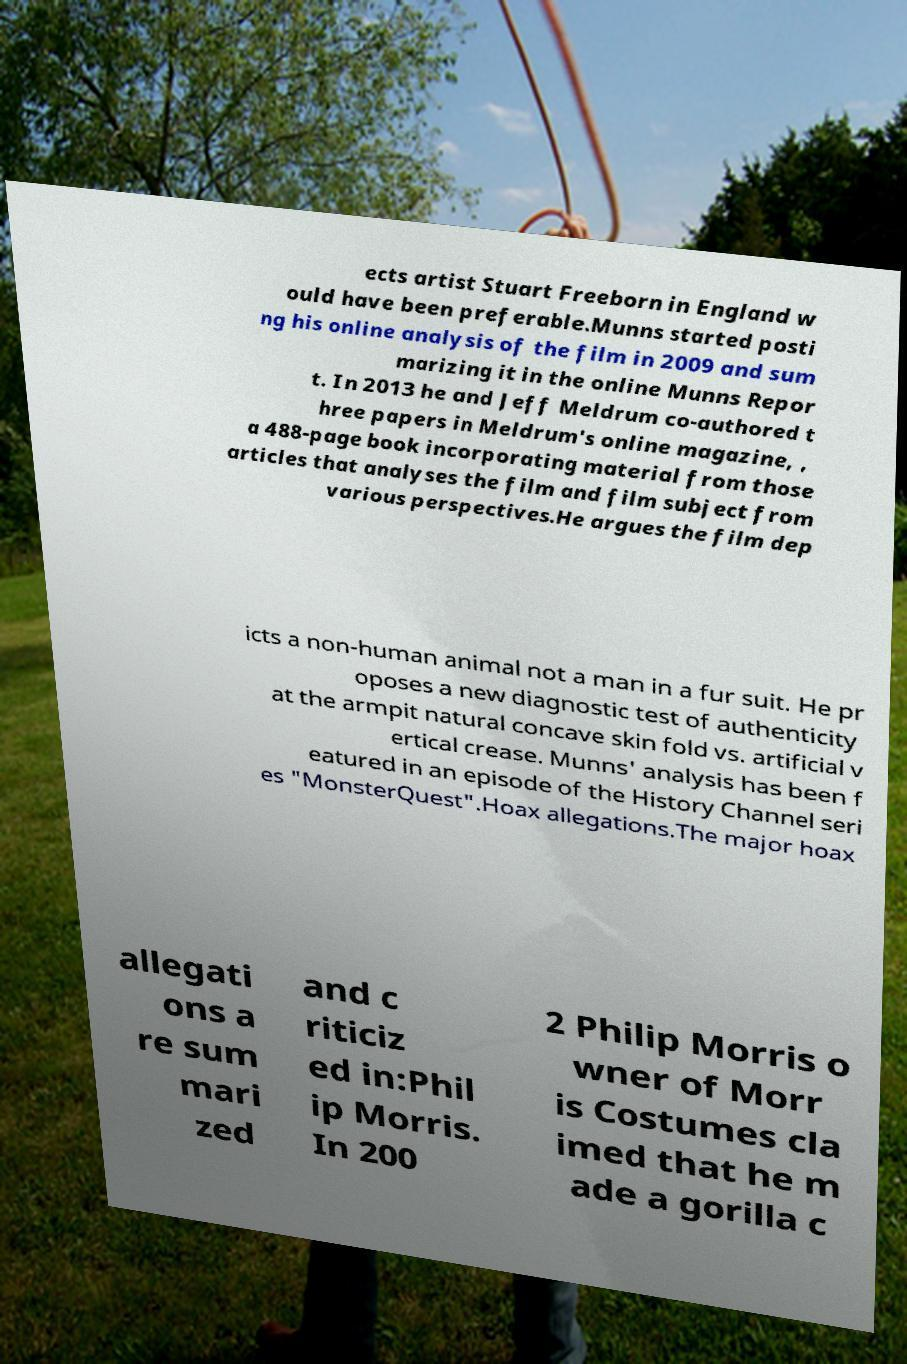Can you read and provide the text displayed in the image?This photo seems to have some interesting text. Can you extract and type it out for me? ects artist Stuart Freeborn in England w ould have been preferable.Munns started posti ng his online analysis of the film in 2009 and sum marizing it in the online Munns Repor t. In 2013 he and Jeff Meldrum co-authored t hree papers in Meldrum's online magazine, , a 488-page book incorporating material from those articles that analyses the film and film subject from various perspectives.He argues the film dep icts a non-human animal not a man in a fur suit. He pr oposes a new diagnostic test of authenticity at the armpit natural concave skin fold vs. artificial v ertical crease. Munns' analysis has been f eatured in an episode of the History Channel seri es "MonsterQuest".Hoax allegations.The major hoax allegati ons a re sum mari zed and c riticiz ed in:Phil ip Morris. In 200 2 Philip Morris o wner of Morr is Costumes cla imed that he m ade a gorilla c 